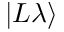<formula> <loc_0><loc_0><loc_500><loc_500>| L \lambda \rangle</formula> 